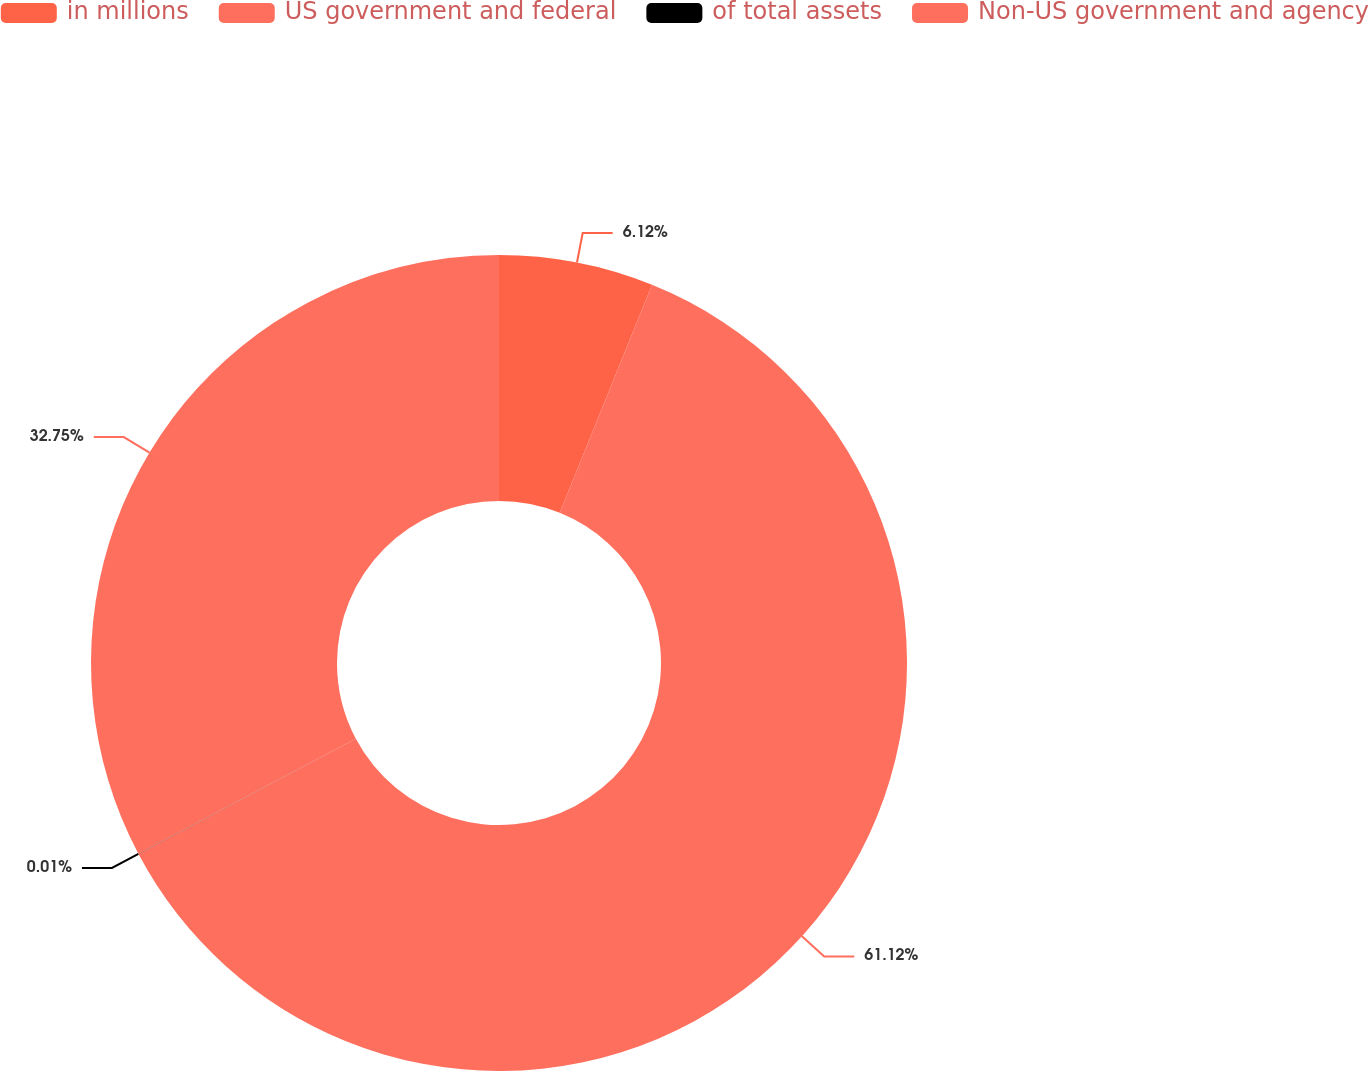Convert chart to OTSL. <chart><loc_0><loc_0><loc_500><loc_500><pie_chart><fcel>in millions<fcel>US government and federal<fcel>of total assets<fcel>Non-US government and agency<nl><fcel>6.12%<fcel>61.13%<fcel>0.01%<fcel>32.75%<nl></chart> 